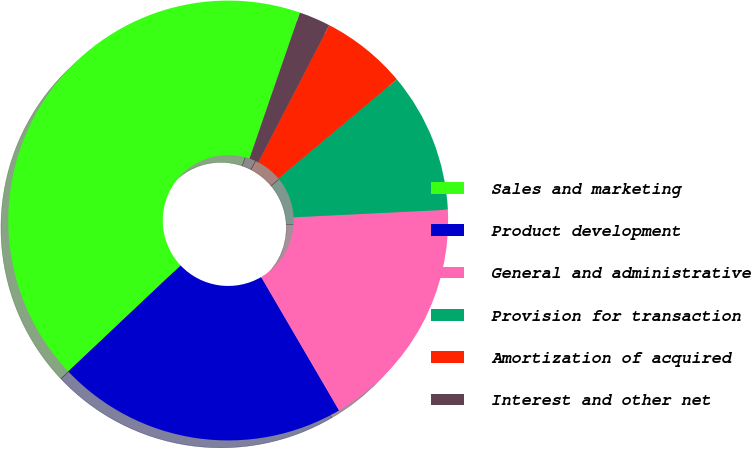Convert chart. <chart><loc_0><loc_0><loc_500><loc_500><pie_chart><fcel>Sales and marketing<fcel>Product development<fcel>General and administrative<fcel>Provision for transaction<fcel>Amortization of acquired<fcel>Interest and other net<nl><fcel>42.32%<fcel>21.37%<fcel>17.37%<fcel>10.31%<fcel>6.31%<fcel>2.31%<nl></chart> 